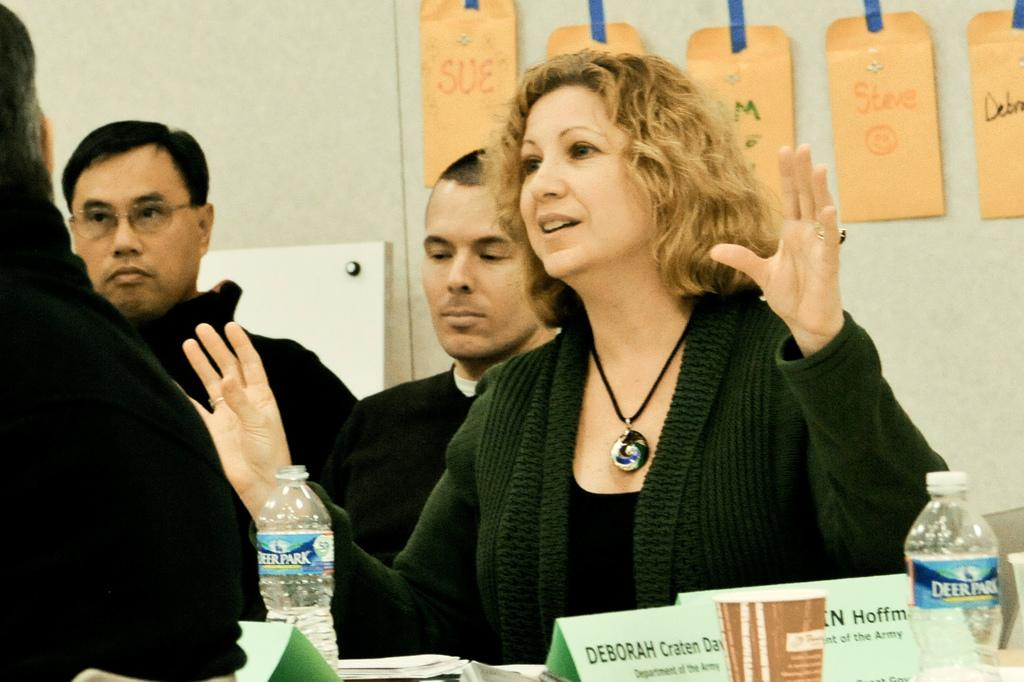How many people are present in the image? There are four people in the image. What objects are in front of the people? There are bottles, at least one cup, and papers in front of the people. What type of scarf is draped around the neck of the person in the image? There is no scarf visible in the image. 